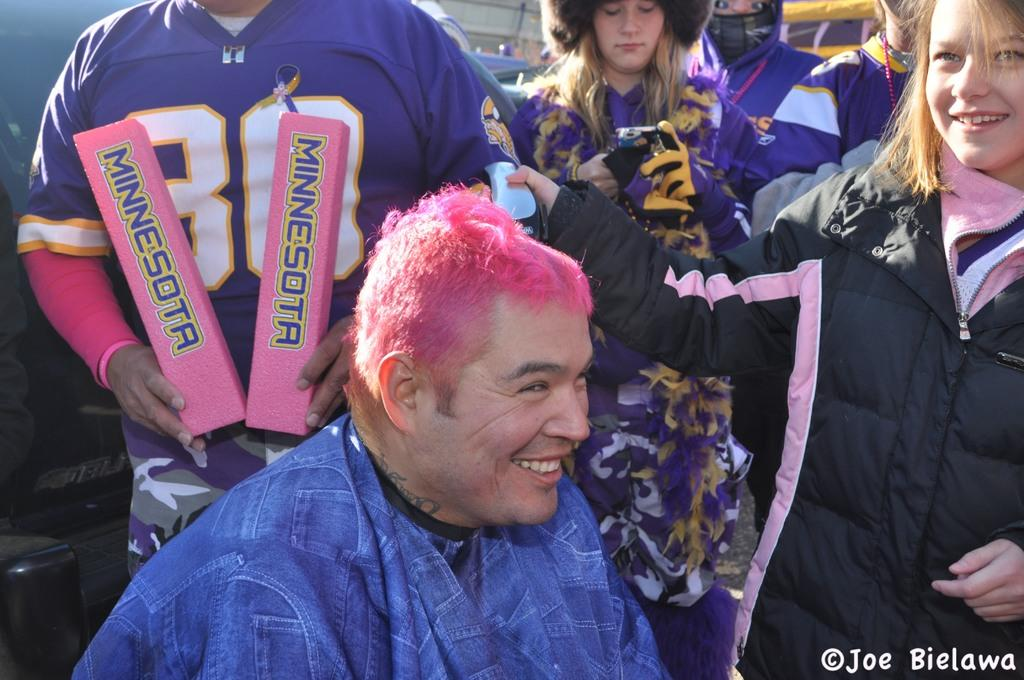<image>
Present a compact description of the photo's key features. A person with pink hair laughs with other Minnesota fans. 